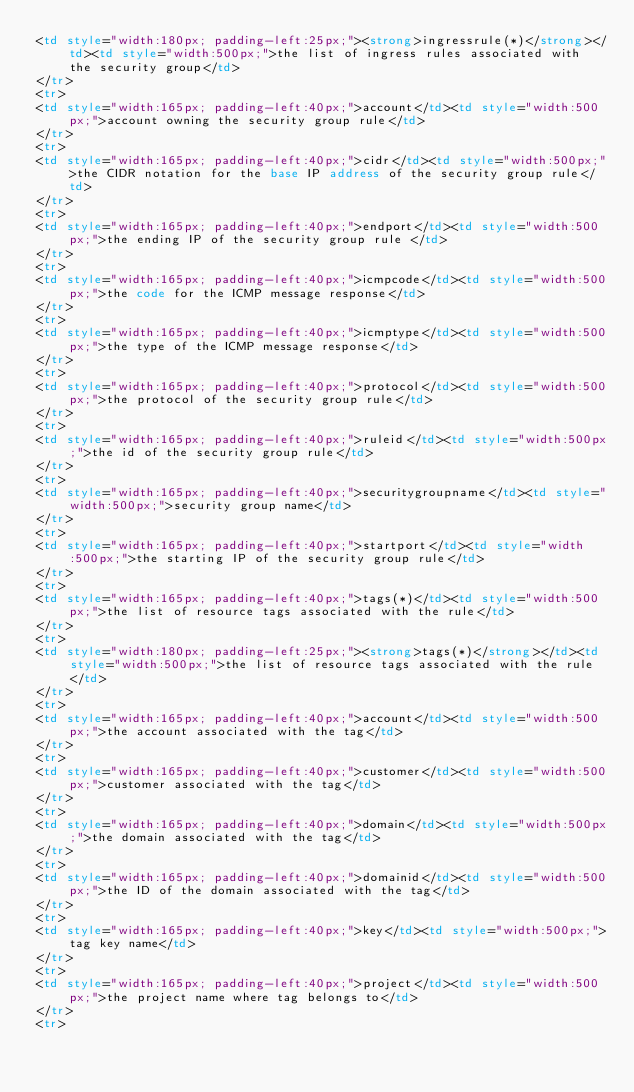Convert code to text. <code><loc_0><loc_0><loc_500><loc_500><_HTML_><td style="width:180px; padding-left:25px;"><strong>ingressrule(*)</strong></td><td style="width:500px;">the list of ingress rules associated with the security group</td>
</tr>
<tr>
<td style="width:165px; padding-left:40px;">account</td><td style="width:500px;">account owning the security group rule</td>
</tr>
<tr>
<td style="width:165px; padding-left:40px;">cidr</td><td style="width:500px;">the CIDR notation for the base IP address of the security group rule</td>
</tr>
<tr>
<td style="width:165px; padding-left:40px;">endport</td><td style="width:500px;">the ending IP of the security group rule </td>
</tr>
<tr>
<td style="width:165px; padding-left:40px;">icmpcode</td><td style="width:500px;">the code for the ICMP message response</td>
</tr>
<tr>
<td style="width:165px; padding-left:40px;">icmptype</td><td style="width:500px;">the type of the ICMP message response</td>
</tr>
<tr>
<td style="width:165px; padding-left:40px;">protocol</td><td style="width:500px;">the protocol of the security group rule</td>
</tr>
<tr>
<td style="width:165px; padding-left:40px;">ruleid</td><td style="width:500px;">the id of the security group rule</td>
</tr>
<tr>
<td style="width:165px; padding-left:40px;">securitygroupname</td><td style="width:500px;">security group name</td>
</tr>
<tr>
<td style="width:165px; padding-left:40px;">startport</td><td style="width:500px;">the starting IP of the security group rule</td>
</tr>
<tr>
<td style="width:165px; padding-left:40px;">tags(*)</td><td style="width:500px;">the list of resource tags associated with the rule</td>
</tr>
<tr>
<td style="width:180px; padding-left:25px;"><strong>tags(*)</strong></td><td style="width:500px;">the list of resource tags associated with the rule</td>
</tr>
<tr>
<td style="width:165px; padding-left:40px;">account</td><td style="width:500px;">the account associated with the tag</td>
</tr>
<tr>
<td style="width:165px; padding-left:40px;">customer</td><td style="width:500px;">customer associated with the tag</td>
</tr>
<tr>
<td style="width:165px; padding-left:40px;">domain</td><td style="width:500px;">the domain associated with the tag</td>
</tr>
<tr>
<td style="width:165px; padding-left:40px;">domainid</td><td style="width:500px;">the ID of the domain associated with the tag</td>
</tr>
<tr>
<td style="width:165px; padding-left:40px;">key</td><td style="width:500px;">tag key name</td>
</tr>
<tr>
<td style="width:165px; padding-left:40px;">project</td><td style="width:500px;">the project name where tag belongs to</td>
</tr>
<tr></code> 